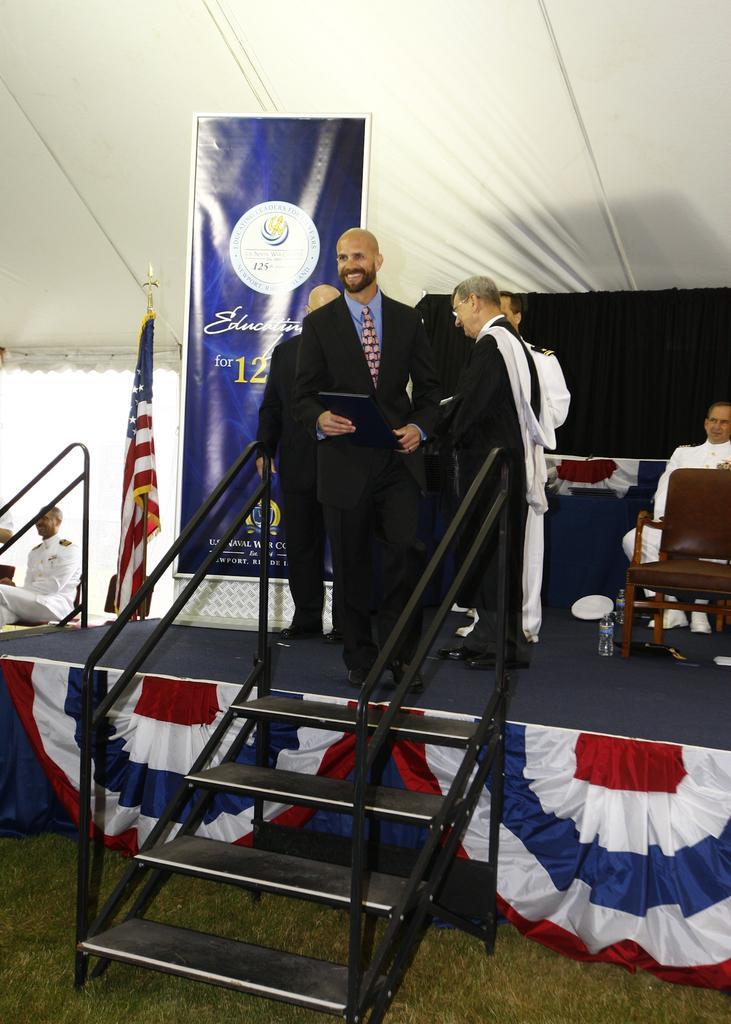Can you describe this image briefly? In this image, few peoples are there on the stage. The background, we can see a blue color curtain and white color tint. On left side, there is a flag. banner, a human is sat on the table. On the bottom we can see a grass. Black color stairs. 